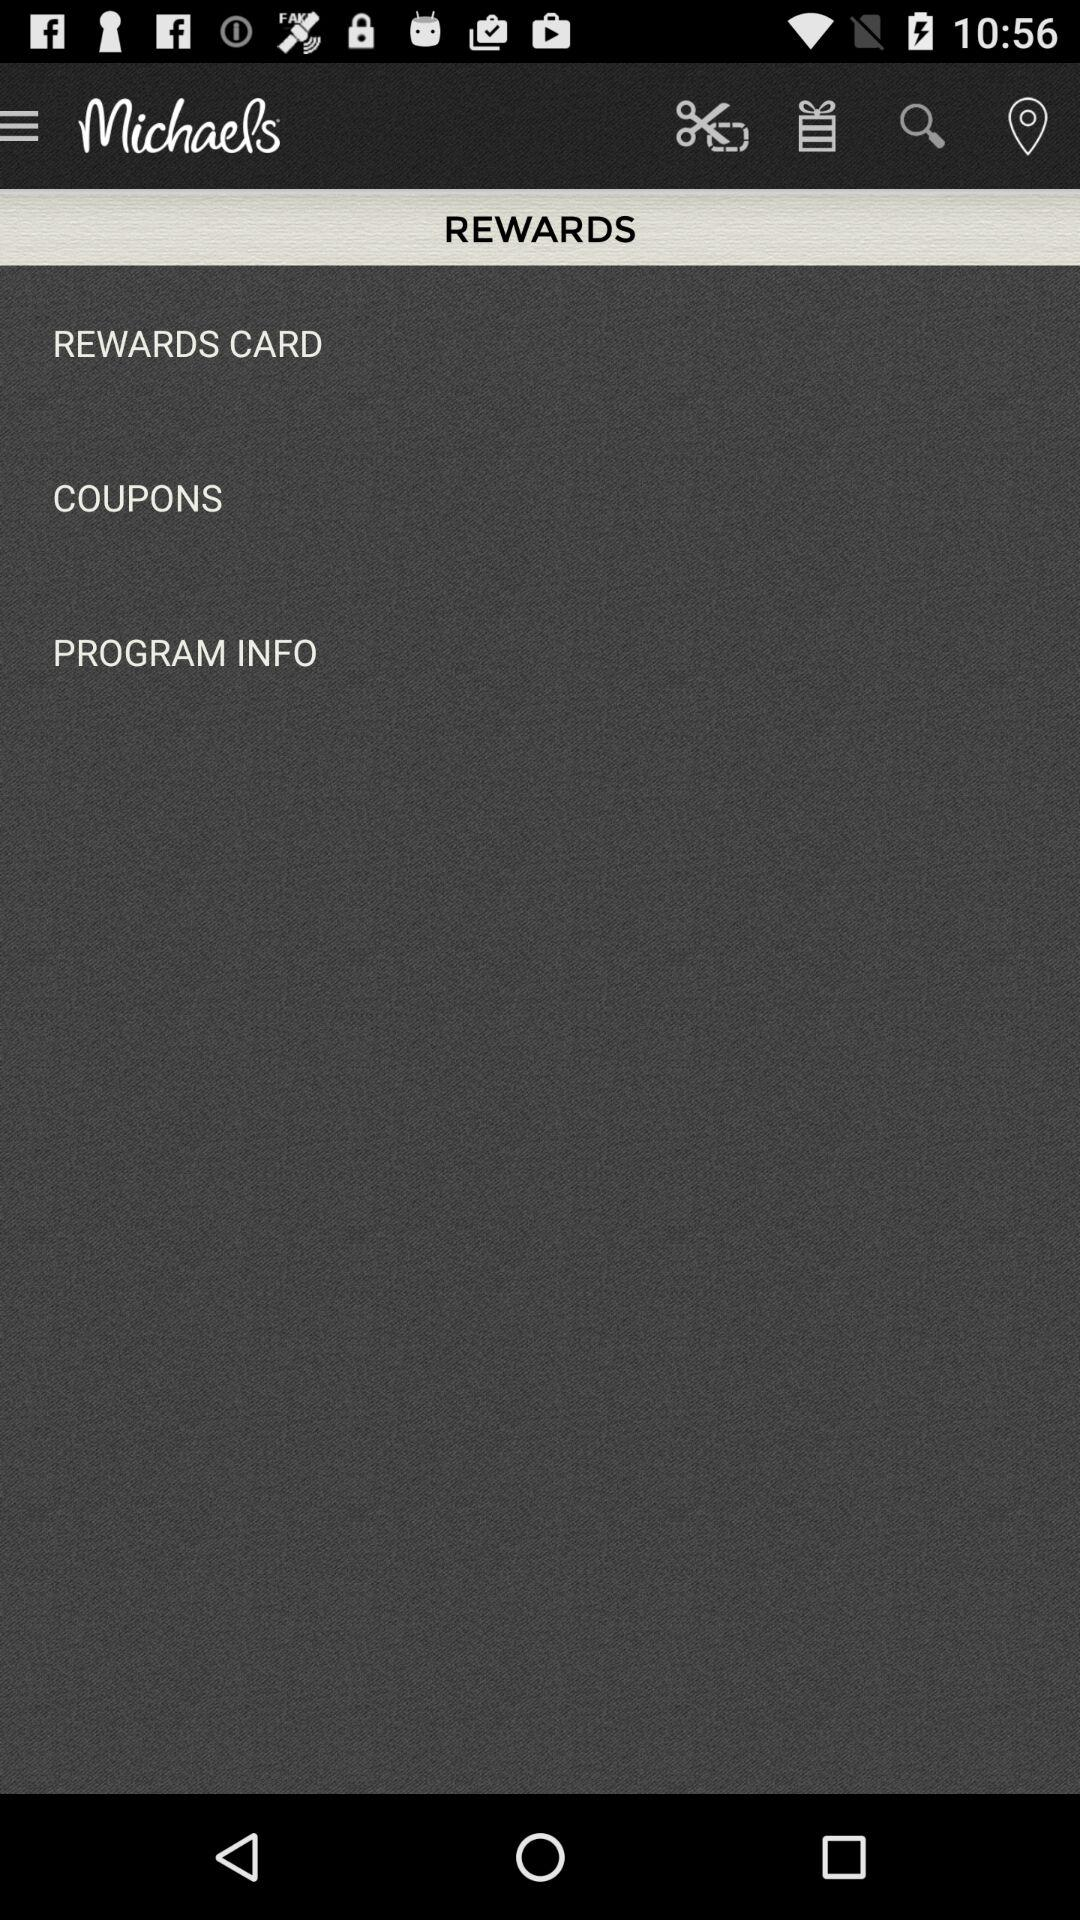What is the application name? The application name is "Michaels". 